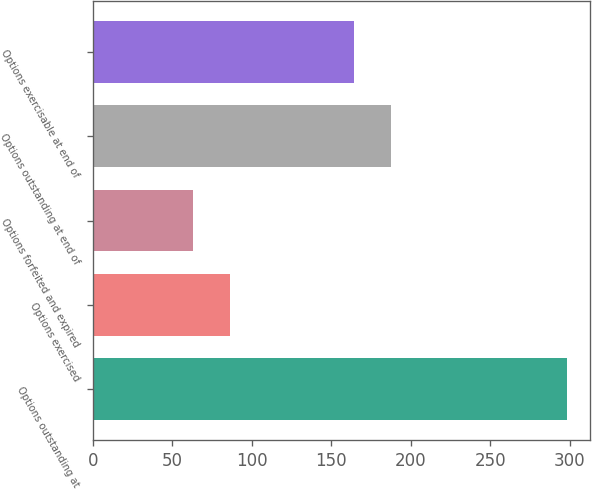Convert chart. <chart><loc_0><loc_0><loc_500><loc_500><bar_chart><fcel>Options outstanding at<fcel>Options exercised<fcel>Options forfeited and expired<fcel>Options outstanding at end of<fcel>Options exercisable at end of<nl><fcel>298<fcel>86.5<fcel>63<fcel>187.5<fcel>164<nl></chart> 